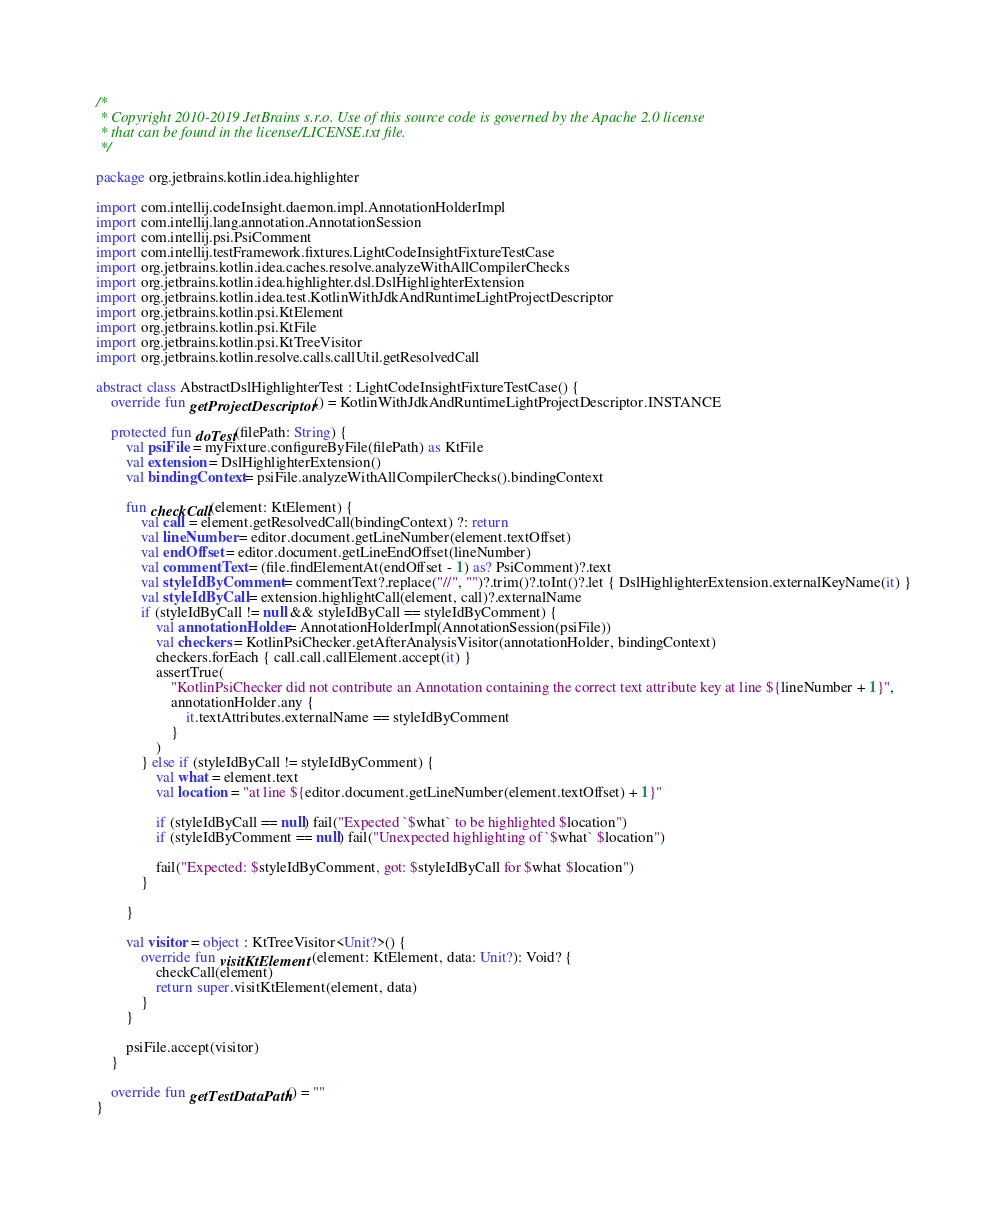<code> <loc_0><loc_0><loc_500><loc_500><_Kotlin_>/*
 * Copyright 2010-2019 JetBrains s.r.o. Use of this source code is governed by the Apache 2.0 license
 * that can be found in the license/LICENSE.txt file.
 */

package org.jetbrains.kotlin.idea.highlighter

import com.intellij.codeInsight.daemon.impl.AnnotationHolderImpl
import com.intellij.lang.annotation.AnnotationSession
import com.intellij.psi.PsiComment
import com.intellij.testFramework.fixtures.LightCodeInsightFixtureTestCase
import org.jetbrains.kotlin.idea.caches.resolve.analyzeWithAllCompilerChecks
import org.jetbrains.kotlin.idea.highlighter.dsl.DslHighlighterExtension
import org.jetbrains.kotlin.idea.test.KotlinWithJdkAndRuntimeLightProjectDescriptor
import org.jetbrains.kotlin.psi.KtElement
import org.jetbrains.kotlin.psi.KtFile
import org.jetbrains.kotlin.psi.KtTreeVisitor
import org.jetbrains.kotlin.resolve.calls.callUtil.getResolvedCall

abstract class AbstractDslHighlighterTest : LightCodeInsightFixtureTestCase() {
    override fun getProjectDescriptor() = KotlinWithJdkAndRuntimeLightProjectDescriptor.INSTANCE

    protected fun doTest(filePath: String) {
        val psiFile = myFixture.configureByFile(filePath) as KtFile
        val extension = DslHighlighterExtension()
        val bindingContext = psiFile.analyzeWithAllCompilerChecks().bindingContext

        fun checkCall(element: KtElement) {
            val call = element.getResolvedCall(bindingContext) ?: return
            val lineNumber = editor.document.getLineNumber(element.textOffset)
            val endOffset = editor.document.getLineEndOffset(lineNumber)
            val commentText = (file.findElementAt(endOffset - 1) as? PsiComment)?.text
            val styleIdByComment = commentText?.replace("//", "")?.trim()?.toInt()?.let { DslHighlighterExtension.externalKeyName(it) }
            val styleIdByCall = extension.highlightCall(element, call)?.externalName
            if (styleIdByCall != null && styleIdByCall == styleIdByComment) {
                val annotationHolder = AnnotationHolderImpl(AnnotationSession(psiFile))
                val checkers = KotlinPsiChecker.getAfterAnalysisVisitor(annotationHolder, bindingContext)
                checkers.forEach { call.call.callElement.accept(it) }
                assertTrue(
                    "KotlinPsiChecker did not contribute an Annotation containing the correct text attribute key at line ${lineNumber + 1}",
                    annotationHolder.any {
                        it.textAttributes.externalName == styleIdByComment
                    }
                )
            } else if (styleIdByCall != styleIdByComment) {
                val what = element.text
                val location = "at line ${editor.document.getLineNumber(element.textOffset) + 1}"

                if (styleIdByCall == null) fail("Expected `$what` to be highlighted $location")
                if (styleIdByComment == null) fail("Unexpected highlighting of `$what` $location")

                fail("Expected: $styleIdByComment, got: $styleIdByCall for $what $location")
            }

        }

        val visitor = object : KtTreeVisitor<Unit?>() {
            override fun visitKtElement(element: KtElement, data: Unit?): Void? {
                checkCall(element)
                return super.visitKtElement(element, data)
            }
        }

        psiFile.accept(visitor)
    }

    override fun getTestDataPath() = ""
}</code> 